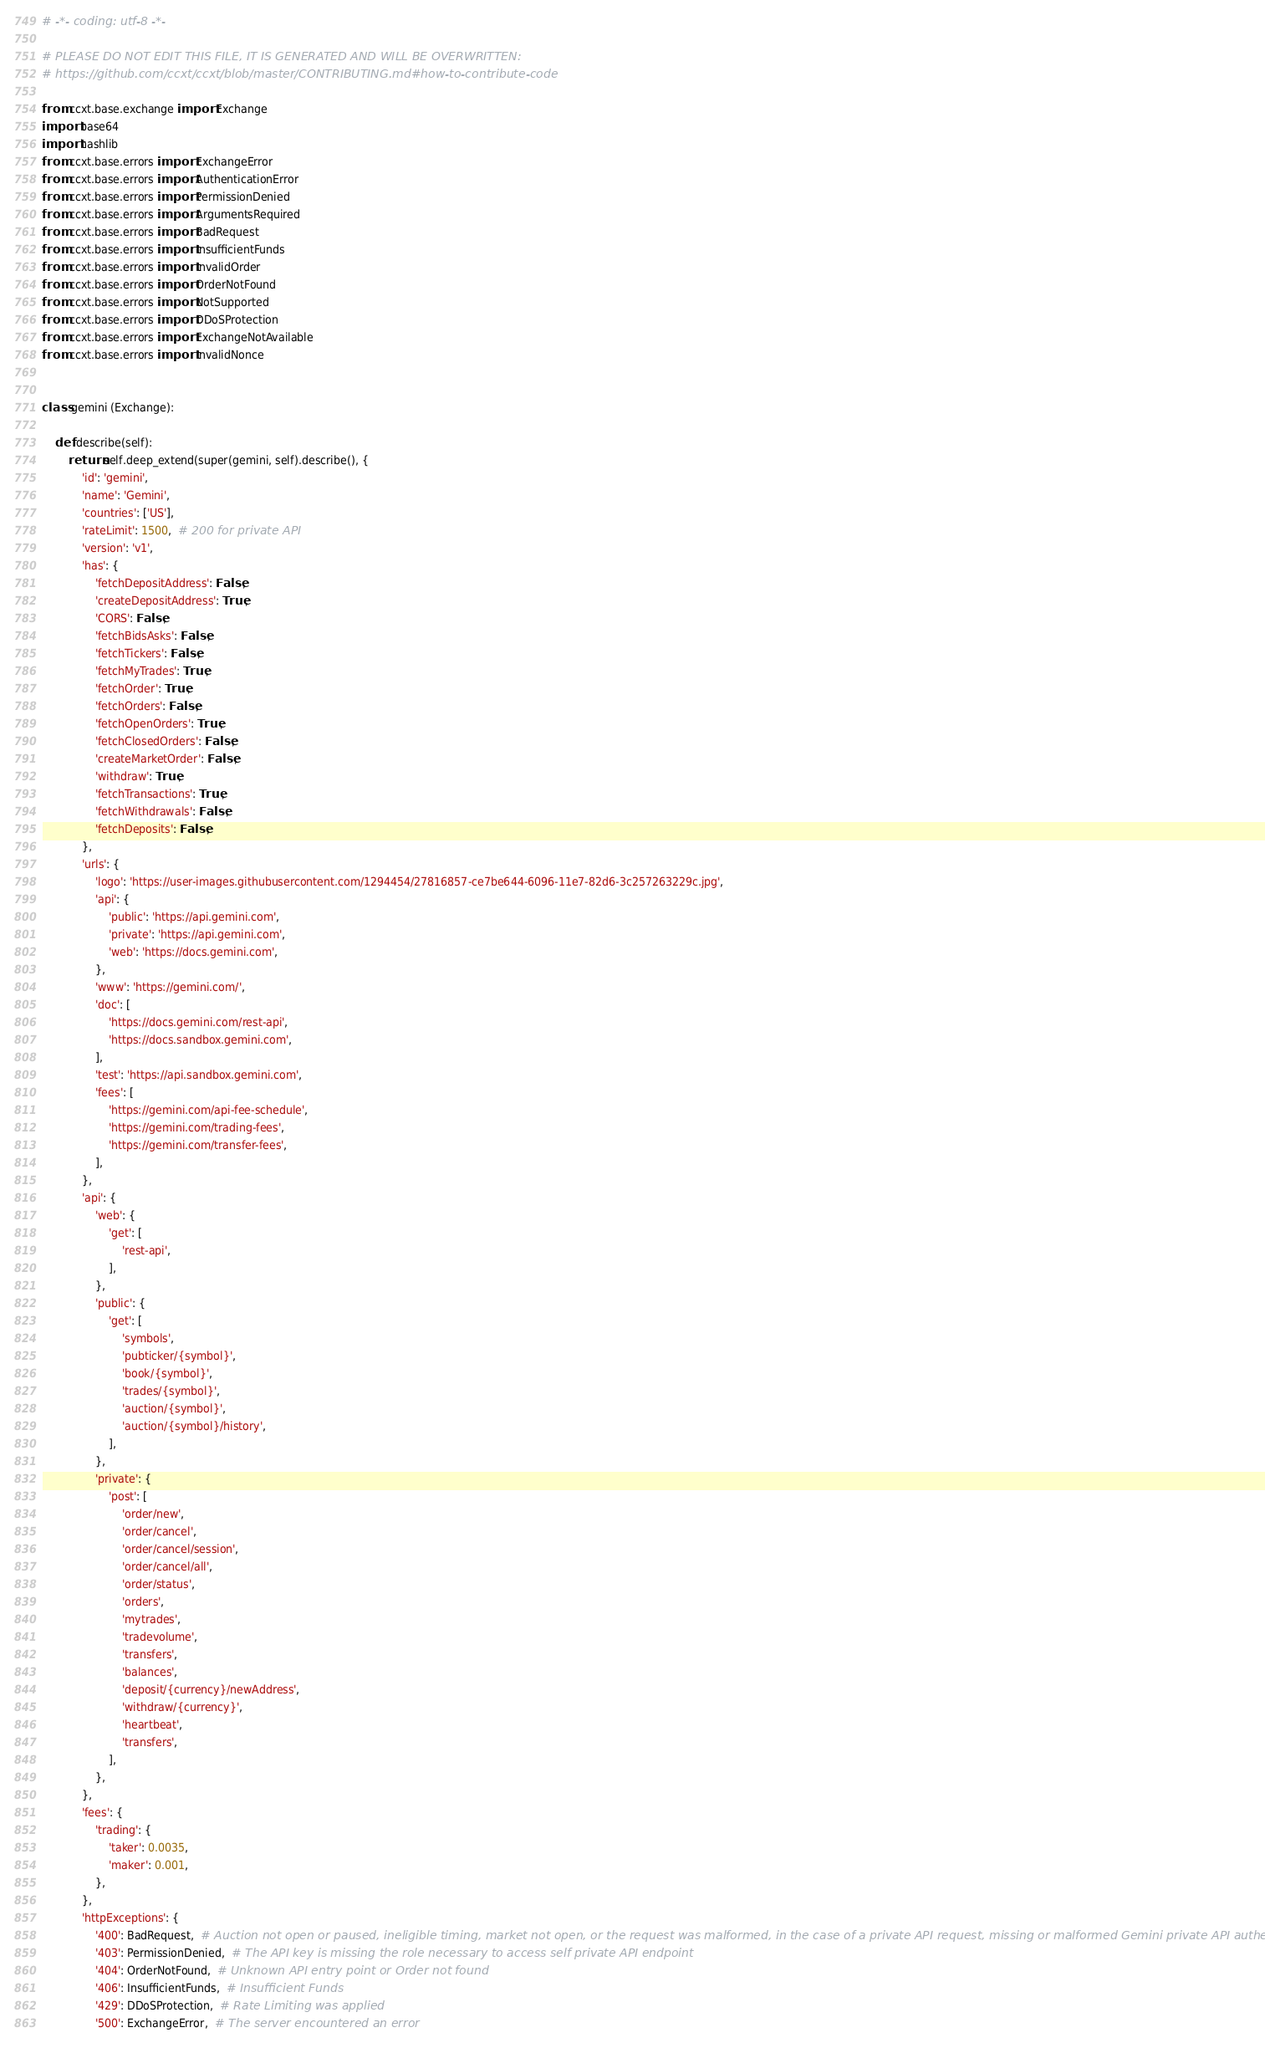<code> <loc_0><loc_0><loc_500><loc_500><_Python_># -*- coding: utf-8 -*-

# PLEASE DO NOT EDIT THIS FILE, IT IS GENERATED AND WILL BE OVERWRITTEN:
# https://github.com/ccxt/ccxt/blob/master/CONTRIBUTING.md#how-to-contribute-code

from ccxt.base.exchange import Exchange
import base64
import hashlib
from ccxt.base.errors import ExchangeError
from ccxt.base.errors import AuthenticationError
from ccxt.base.errors import PermissionDenied
from ccxt.base.errors import ArgumentsRequired
from ccxt.base.errors import BadRequest
from ccxt.base.errors import InsufficientFunds
from ccxt.base.errors import InvalidOrder
from ccxt.base.errors import OrderNotFound
from ccxt.base.errors import NotSupported
from ccxt.base.errors import DDoSProtection
from ccxt.base.errors import ExchangeNotAvailable
from ccxt.base.errors import InvalidNonce


class gemini (Exchange):

    def describe(self):
        return self.deep_extend(super(gemini, self).describe(), {
            'id': 'gemini',
            'name': 'Gemini',
            'countries': ['US'],
            'rateLimit': 1500,  # 200 for private API
            'version': 'v1',
            'has': {
                'fetchDepositAddress': False,
                'createDepositAddress': True,
                'CORS': False,
                'fetchBidsAsks': False,
                'fetchTickers': False,
                'fetchMyTrades': True,
                'fetchOrder': True,
                'fetchOrders': False,
                'fetchOpenOrders': True,
                'fetchClosedOrders': False,
                'createMarketOrder': False,
                'withdraw': True,
                'fetchTransactions': True,
                'fetchWithdrawals': False,
                'fetchDeposits': False,
            },
            'urls': {
                'logo': 'https://user-images.githubusercontent.com/1294454/27816857-ce7be644-6096-11e7-82d6-3c257263229c.jpg',
                'api': {
                    'public': 'https://api.gemini.com',
                    'private': 'https://api.gemini.com',
                    'web': 'https://docs.gemini.com',
                },
                'www': 'https://gemini.com/',
                'doc': [
                    'https://docs.gemini.com/rest-api',
                    'https://docs.sandbox.gemini.com',
                ],
                'test': 'https://api.sandbox.gemini.com',
                'fees': [
                    'https://gemini.com/api-fee-schedule',
                    'https://gemini.com/trading-fees',
                    'https://gemini.com/transfer-fees',
                ],
            },
            'api': {
                'web': {
                    'get': [
                        'rest-api',
                    ],
                },
                'public': {
                    'get': [
                        'symbols',
                        'pubticker/{symbol}',
                        'book/{symbol}',
                        'trades/{symbol}',
                        'auction/{symbol}',
                        'auction/{symbol}/history',
                    ],
                },
                'private': {
                    'post': [
                        'order/new',
                        'order/cancel',
                        'order/cancel/session',
                        'order/cancel/all',
                        'order/status',
                        'orders',
                        'mytrades',
                        'tradevolume',
                        'transfers',
                        'balances',
                        'deposit/{currency}/newAddress',
                        'withdraw/{currency}',
                        'heartbeat',
                        'transfers',
                    ],
                },
            },
            'fees': {
                'trading': {
                    'taker': 0.0035,
                    'maker': 0.001,
                },
            },
            'httpExceptions': {
                '400': BadRequest,  # Auction not open or paused, ineligible timing, market not open, or the request was malformed, in the case of a private API request, missing or malformed Gemini private API authentication headers
                '403': PermissionDenied,  # The API key is missing the role necessary to access self private API endpoint
                '404': OrderNotFound,  # Unknown API entry point or Order not found
                '406': InsufficientFunds,  # Insufficient Funds
                '429': DDoSProtection,  # Rate Limiting was applied
                '500': ExchangeError,  # The server encountered an error</code> 